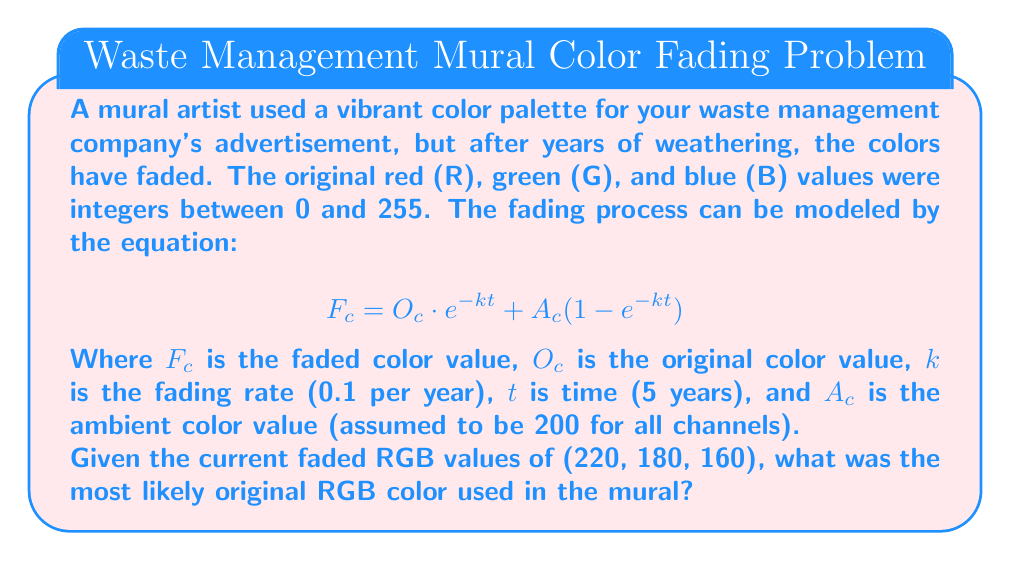Show me your answer to this math problem. To solve this inverse problem, we need to work backwards from the faded colors to the original colors. Let's follow these steps:

1) First, we'll rearrange the fading equation to solve for $O_c$:

   $$O_c = \frac{F_c - A_c(1 - e^{-kt})}{e^{-kt}}$$

2) We know the following values:
   $F_c$ = (220, 180, 160) for (R, G, B)
   $A_c$ = 200 for all channels
   $k$ = 0.1 per year
   $t$ = 5 years

3) Let's calculate $e^{-kt}$:
   $$e^{-kt} = e^{-0.1 \cdot 5} = e^{-0.5} \approx 0.6065$$

4) Now, let's calculate the original color values for each channel:

   For Red:
   $$O_R = \frac{220 - 200(1 - 0.6065)}{0.6065} \approx 253.4$$

   For Green:
   $$O_G = \frac{180 - 200(1 - 0.6065)}{0.6065} \approx 186.8$$

   For Blue:
   $$O_B = \frac{160 - 200(1 - 0.6065)}{0.6065} \approx 153.5$$

5) Since we know the original values were integers between 0 and 255, we round these values to the nearest integer:

   $R \approx 253$
   $G \approx 187$
   $B \approx 154$

Therefore, the most likely original RGB color used in the mural was (253, 187, 154).
Answer: (253, 187, 154) 